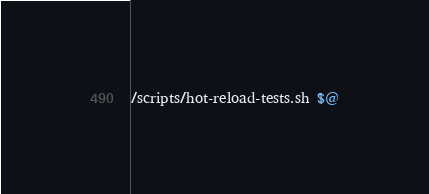<code> <loc_0><loc_0><loc_500><loc_500><_Bash_>/scripts/hot-reload-tests.sh $@</code> 